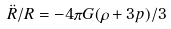<formula> <loc_0><loc_0><loc_500><loc_500>\ddot { R } / R = - 4 \pi G ( \rho + 3 p ) / 3</formula> 